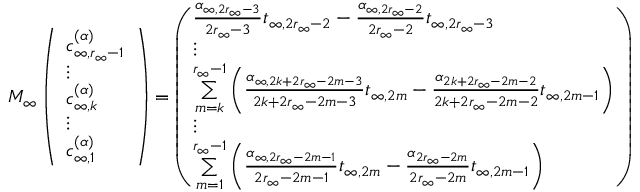<formula> <loc_0><loc_0><loc_500><loc_500>M _ { \infty } \left ( \begin{array} { l } { c _ { \infty , r _ { \infty } - 1 } ^ { ( \alpha ) } } \\ { \vdots } \\ { c _ { \infty , k } ^ { ( \alpha ) } } \\ { \vdots } \\ { c _ { \infty , 1 } ^ { ( \alpha ) } } \end{array} \right ) = \left ( \begin{array} { l } { \frac { \alpha _ { \infty , 2 r _ { \infty } - 3 } } { 2 r _ { \infty } - 3 } t _ { \infty , 2 r _ { \infty } - 2 } - \frac { \alpha _ { \infty , 2 r _ { \infty } - 2 } } { 2 r _ { \infty } - 2 } t _ { \infty , 2 r _ { \infty } - 3 } } \\ { \vdots } \\ { \underset { m = k } { \overset { r _ { \infty } - 1 } { \sum } } \left ( \frac { \alpha _ { \infty , 2 k + 2 r _ { \infty } - 2 m - 3 } } { 2 k + 2 r _ { \infty } - 2 m - 3 } t _ { \infty , 2 m } - \frac { \alpha _ { 2 k + 2 r _ { \infty } - 2 m - 2 } } { 2 k + 2 r _ { \infty } - 2 m - 2 } t _ { \infty , 2 m - 1 } \right ) } \\ { \vdots } \\ { \underset { m = 1 } { \overset { r _ { \infty } - 1 } { \sum } } \left ( \frac { \alpha _ { \infty , 2 r _ { \infty } - 2 m - 1 } } { 2 r _ { \infty } - 2 m - 1 } t _ { \infty , 2 m } - \frac { \alpha _ { 2 r _ { \infty } - 2 m } } { 2 r _ { \infty } - 2 m } t _ { \infty , 2 m - 1 } \right ) } \end{array} \right )</formula> 